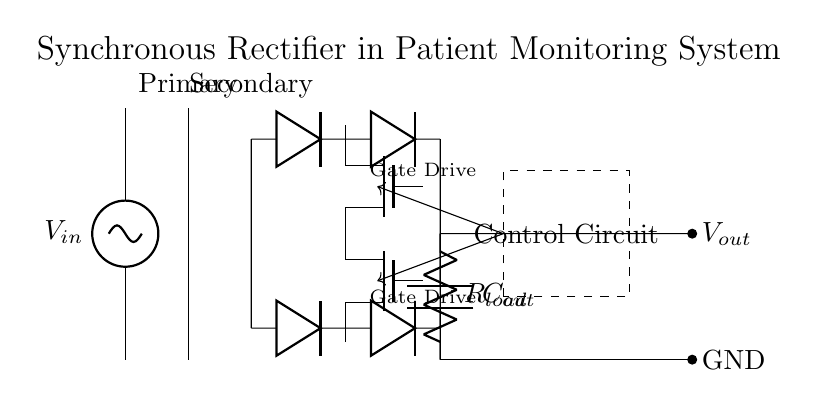What is the type of rectifier used in this circuit? The circuit uses a synchronous rectifier, which is indicated by the presence of the MOSFETs instead of traditional diodes.
Answer: synchronous rectifier What components are used to control the MOSFETs? The dashed rectangle labeled "Control Circuit" represents the components that control the MOSFETs, providing the necessary gate drive signals.
Answer: Control Circuit How many diodes are present in the bridge rectifier section? There are four diodes present in the bridge rectifier section, as indicated by the two pairs aligned in the diagram.
Answer: four What is the purpose of the output capacitor in the circuit? The output capacitor, labeled Cout, is used to smoothen the DC output voltage by filtering out the ripples from the rectified signal.
Answer: smoothening What happens to the voltage when it passes through the synchronous rectifiers? The synchronous rectifiers minimize the voltage drop compared to traditional diodes, leading to more efficient power conversion.
Answer: minimized voltage drop Identify the output voltage node labeled in the circuit. The output voltage node is labeled as Vout, which signifies the point where the DC output voltage is taken from.
Answer: Vout 